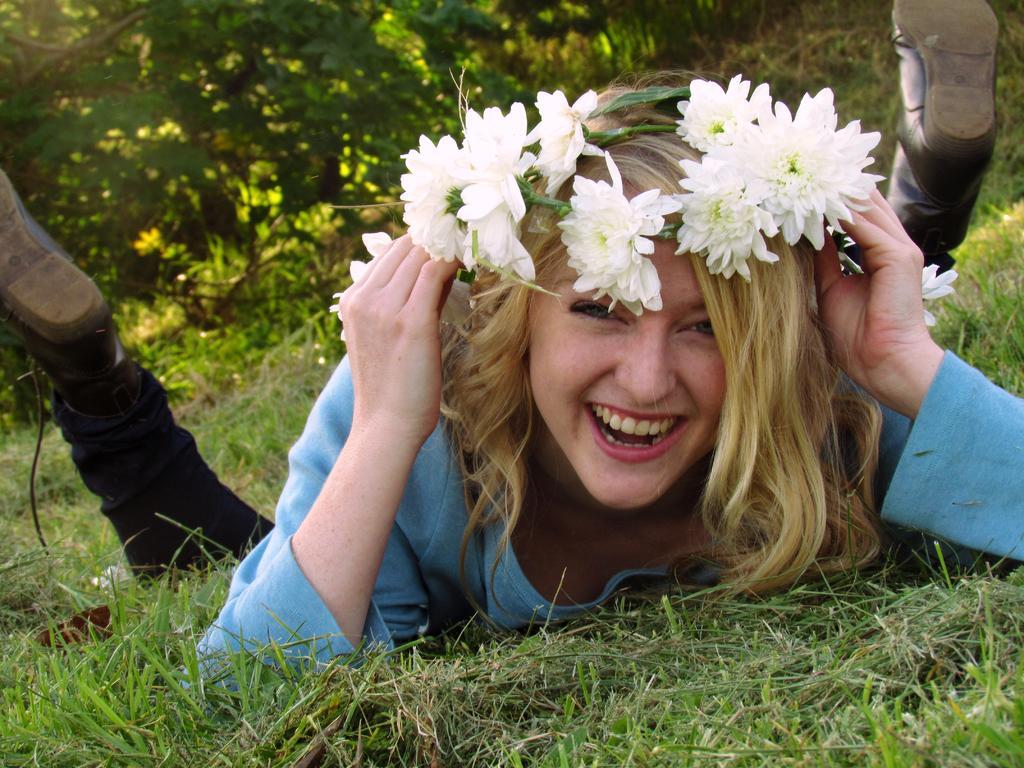Could you give a brief overview of what you see in this image? As we can see in the image there is grass, trees, flowers and a woman over here. 